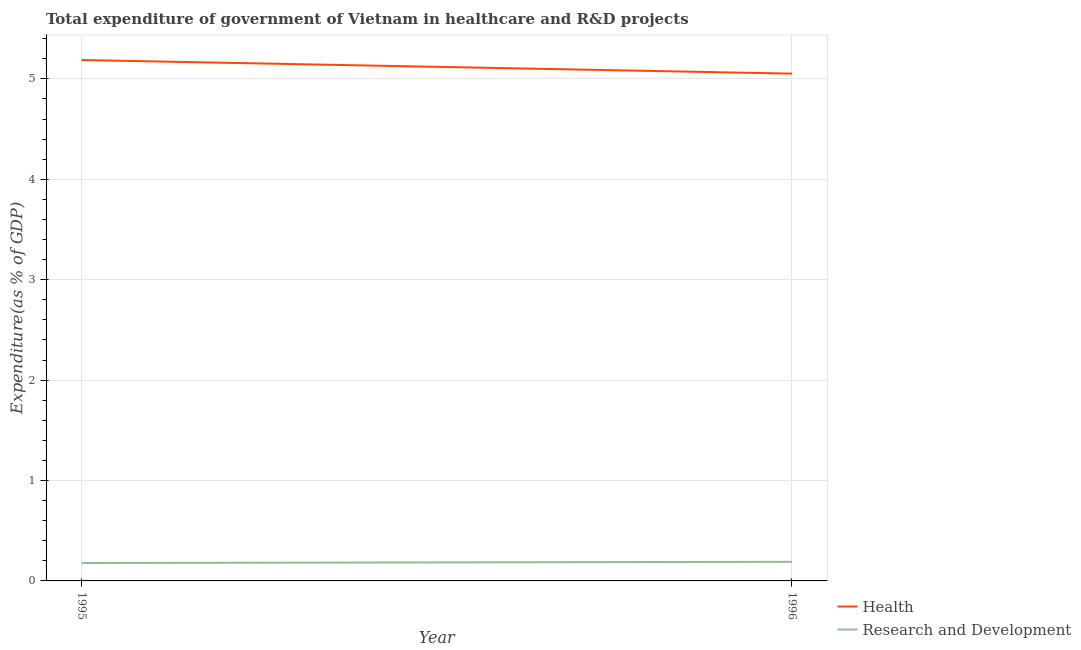Does the line corresponding to expenditure in healthcare intersect with the line corresponding to expenditure in r&d?
Offer a terse response. No. Is the number of lines equal to the number of legend labels?
Ensure brevity in your answer.  Yes. What is the expenditure in healthcare in 1996?
Your answer should be very brief. 5.05. Across all years, what is the maximum expenditure in r&d?
Offer a terse response. 0.19. Across all years, what is the minimum expenditure in r&d?
Your response must be concise. 0.18. What is the total expenditure in r&d in the graph?
Provide a succinct answer. 0.37. What is the difference between the expenditure in healthcare in 1995 and that in 1996?
Keep it short and to the point. 0.14. What is the difference between the expenditure in r&d in 1996 and the expenditure in healthcare in 1995?
Your answer should be compact. -5. What is the average expenditure in r&d per year?
Provide a succinct answer. 0.18. In the year 1996, what is the difference between the expenditure in healthcare and expenditure in r&d?
Make the answer very short. 4.86. What is the ratio of the expenditure in healthcare in 1995 to that in 1996?
Offer a terse response. 1.03. Is the expenditure in healthcare in 1995 less than that in 1996?
Give a very brief answer. No. In how many years, is the expenditure in r&d greater than the average expenditure in r&d taken over all years?
Your answer should be compact. 1. How many years are there in the graph?
Your answer should be very brief. 2. How many legend labels are there?
Your response must be concise. 2. What is the title of the graph?
Make the answer very short. Total expenditure of government of Vietnam in healthcare and R&D projects. Does "Lower secondary education" appear as one of the legend labels in the graph?
Your answer should be very brief. No. What is the label or title of the Y-axis?
Your answer should be compact. Expenditure(as % of GDP). What is the Expenditure(as % of GDP) of Health in 1995?
Your answer should be very brief. 5.19. What is the Expenditure(as % of GDP) in Research and Development in 1995?
Ensure brevity in your answer.  0.18. What is the Expenditure(as % of GDP) in Health in 1996?
Give a very brief answer. 5.05. What is the Expenditure(as % of GDP) in Research and Development in 1996?
Ensure brevity in your answer.  0.19. Across all years, what is the maximum Expenditure(as % of GDP) of Health?
Make the answer very short. 5.19. Across all years, what is the maximum Expenditure(as % of GDP) in Research and Development?
Your answer should be compact. 0.19. Across all years, what is the minimum Expenditure(as % of GDP) in Health?
Offer a terse response. 5.05. Across all years, what is the minimum Expenditure(as % of GDP) of Research and Development?
Provide a succinct answer. 0.18. What is the total Expenditure(as % of GDP) in Health in the graph?
Offer a very short reply. 10.24. What is the total Expenditure(as % of GDP) in Research and Development in the graph?
Keep it short and to the point. 0.37. What is the difference between the Expenditure(as % of GDP) of Health in 1995 and that in 1996?
Make the answer very short. 0.14. What is the difference between the Expenditure(as % of GDP) of Research and Development in 1995 and that in 1996?
Keep it short and to the point. -0.01. What is the difference between the Expenditure(as % of GDP) of Health in 1995 and the Expenditure(as % of GDP) of Research and Development in 1996?
Keep it short and to the point. 5. What is the average Expenditure(as % of GDP) of Health per year?
Your answer should be compact. 5.12. What is the average Expenditure(as % of GDP) in Research and Development per year?
Give a very brief answer. 0.18. In the year 1995, what is the difference between the Expenditure(as % of GDP) in Health and Expenditure(as % of GDP) in Research and Development?
Offer a very short reply. 5.01. In the year 1996, what is the difference between the Expenditure(as % of GDP) in Health and Expenditure(as % of GDP) in Research and Development?
Make the answer very short. 4.86. What is the ratio of the Expenditure(as % of GDP) of Health in 1995 to that in 1996?
Provide a succinct answer. 1.03. What is the ratio of the Expenditure(as % of GDP) in Research and Development in 1995 to that in 1996?
Provide a short and direct response. 0.94. What is the difference between the highest and the second highest Expenditure(as % of GDP) of Health?
Your response must be concise. 0.14. What is the difference between the highest and the second highest Expenditure(as % of GDP) of Research and Development?
Provide a short and direct response. 0.01. What is the difference between the highest and the lowest Expenditure(as % of GDP) in Health?
Give a very brief answer. 0.14. What is the difference between the highest and the lowest Expenditure(as % of GDP) of Research and Development?
Give a very brief answer. 0.01. 